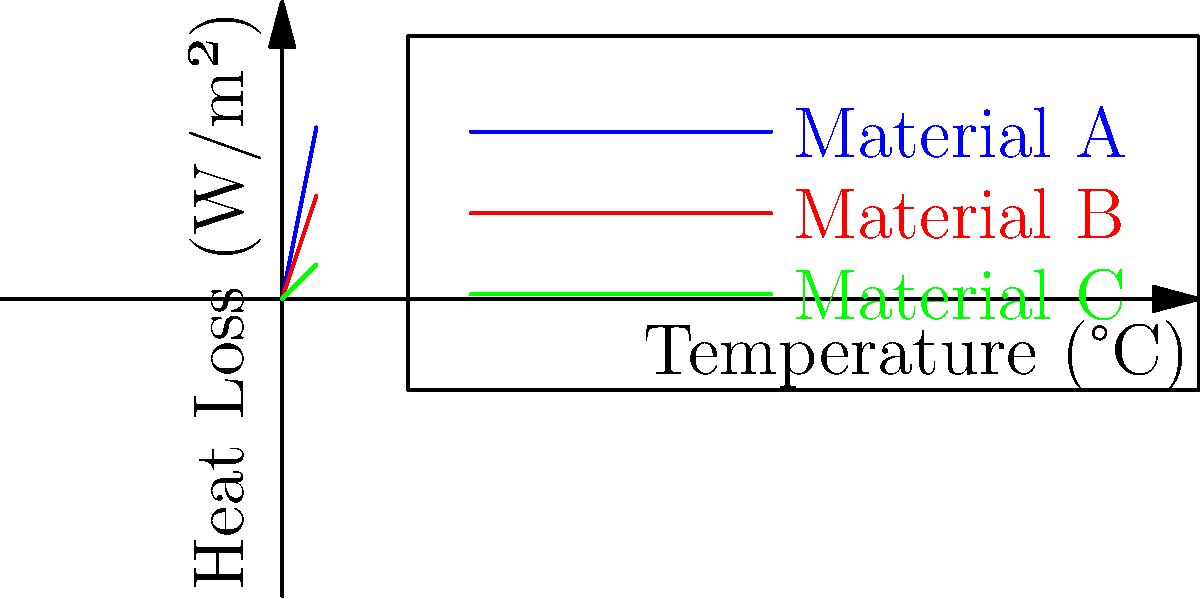As a caretaker designing a temperature-controlled enclosure for polar bears, you need to choose the most effective insulation material. Based on the heat loss curves shown in the graph for three different materials (A, B, and C), which material would be most suitable for maintaining a stable internal temperature with minimal heat loss? To determine the most effective insulation material for the polar bear enclosure, we need to analyze the heat loss curves for each material:

1. Interpret the graph:
   - The x-axis represents temperature difference (°C) between inside and outside the enclosure.
   - The y-axis represents heat loss (W/m²) through the insulation material.
   - A steeper slope indicates higher heat loss for a given temperature difference.

2. Compare the slopes of the three materials:
   - Material A (blue line): Steepest slope, highest heat loss
   - Material B (red line): Intermediate slope, moderate heat loss
   - Material C (green line): Least steep slope, lowest heat loss

3. Consider the implications:
   - Lower heat loss means better insulation performance.
   - Better insulation leads to more stable internal temperatures and lower energy costs for temperature control.

4. Evaluate the materials:
   - Material A would allow the most heat transfer, making it the least effective for insulation.
   - Material B performs better than A but not as well as C.
   - Material C shows the lowest heat loss across all temperature differences, indicating the best insulation properties.

5. Consider the polar bear habitat requirements:
   - Polar bears are adapted to cold environments and need a cool, stable temperature in their enclosure.
   - Minimizing heat gain from the external environment is crucial for maintaining appropriate conditions.

Based on this analysis, Material C would be the most suitable for maintaining a stable internal temperature with minimal heat loss in the polar bear enclosure.
Answer: Material C 